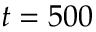<formula> <loc_0><loc_0><loc_500><loc_500>t = 5 0 0</formula> 